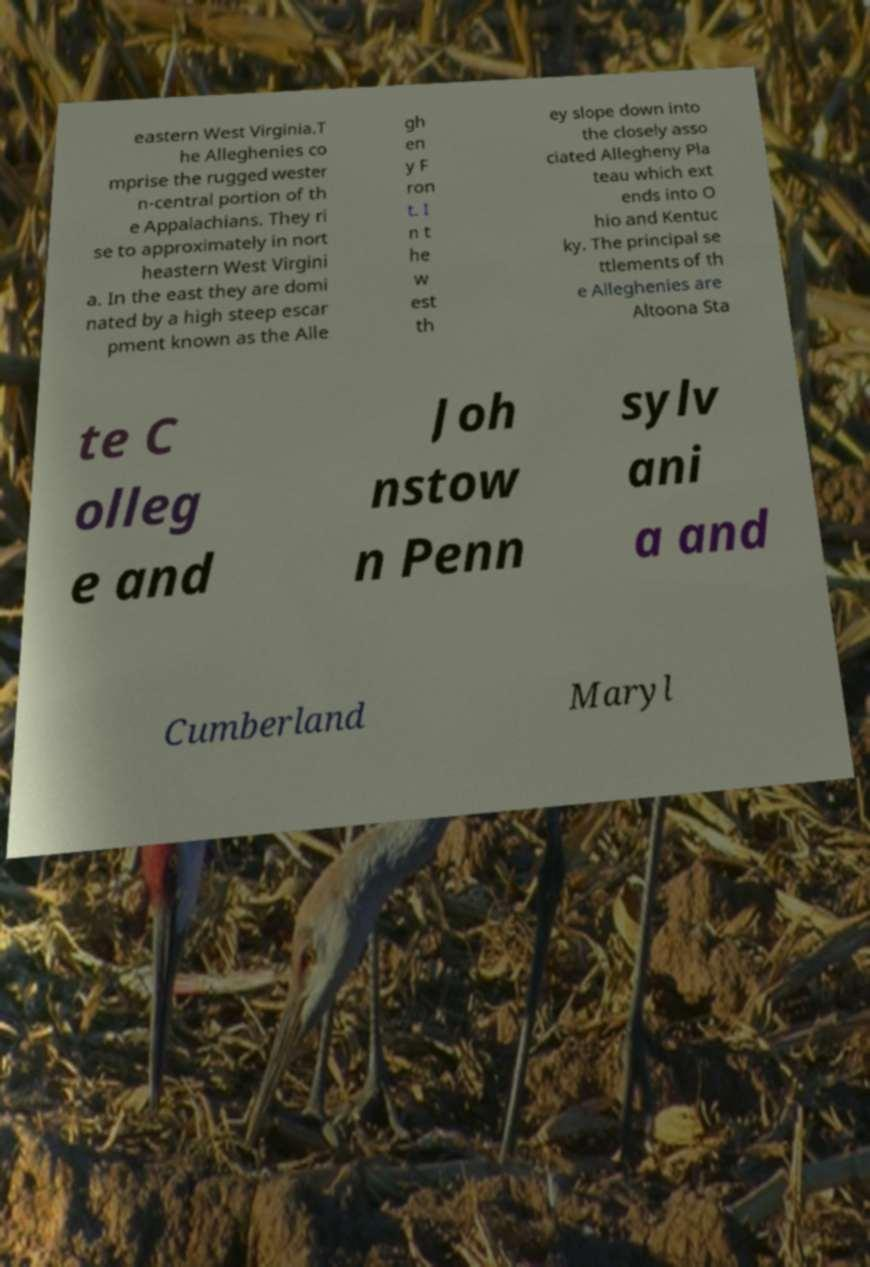I need the written content from this picture converted into text. Can you do that? eastern West Virginia.T he Alleghenies co mprise the rugged wester n-central portion of th e Appalachians. They ri se to approximately in nort heastern West Virgini a. In the east they are domi nated by a high steep escar pment known as the Alle gh en y F ron t. I n t he w est th ey slope down into the closely asso ciated Allegheny Pla teau which ext ends into O hio and Kentuc ky. The principal se ttlements of th e Alleghenies are Altoona Sta te C olleg e and Joh nstow n Penn sylv ani a and Cumberland Maryl 